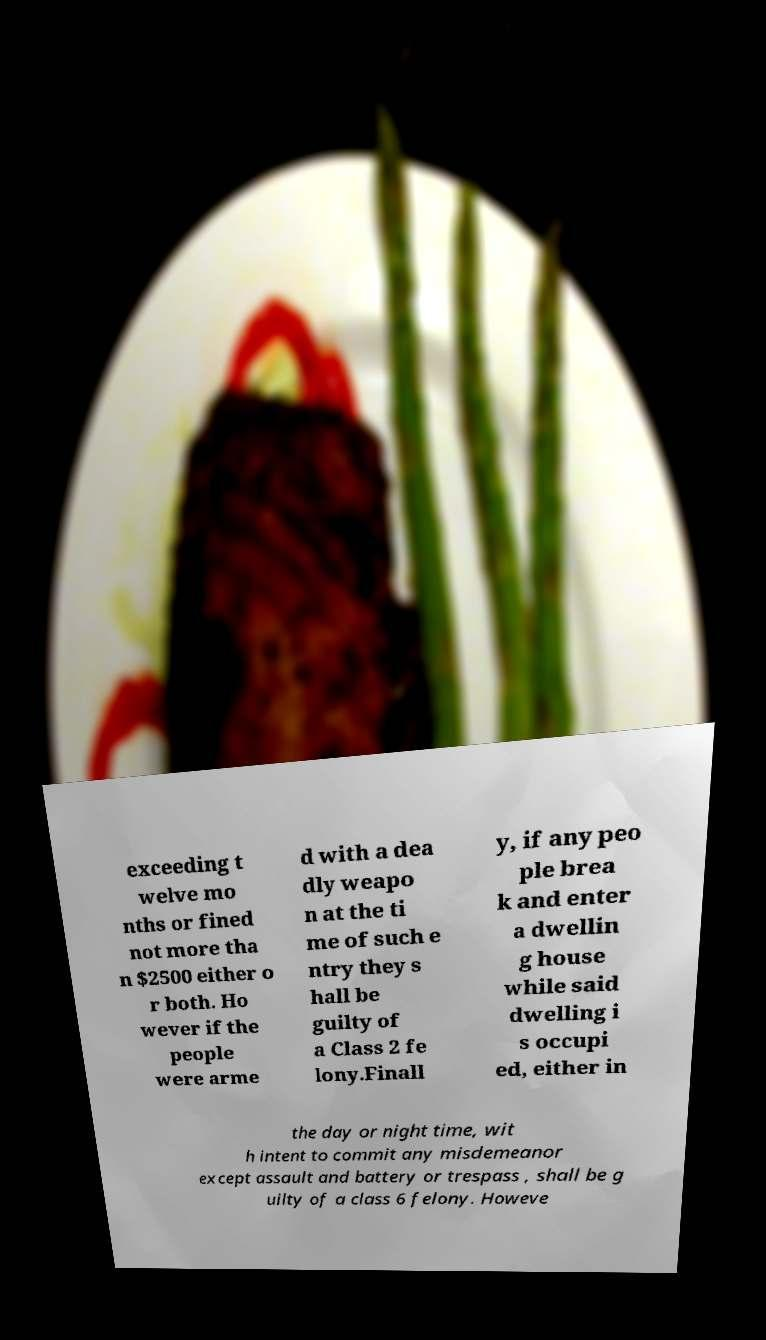What messages or text are displayed in this image? I need them in a readable, typed format. exceeding t welve mo nths or fined not more tha n $2500 either o r both. Ho wever if the people were arme d with a dea dly weapo n at the ti me of such e ntry they s hall be guilty of a Class 2 fe lony.Finall y, if any peo ple brea k and enter a dwellin g house while said dwelling i s occupi ed, either in the day or night time, wit h intent to commit any misdemeanor except assault and battery or trespass , shall be g uilty of a class 6 felony. Howeve 